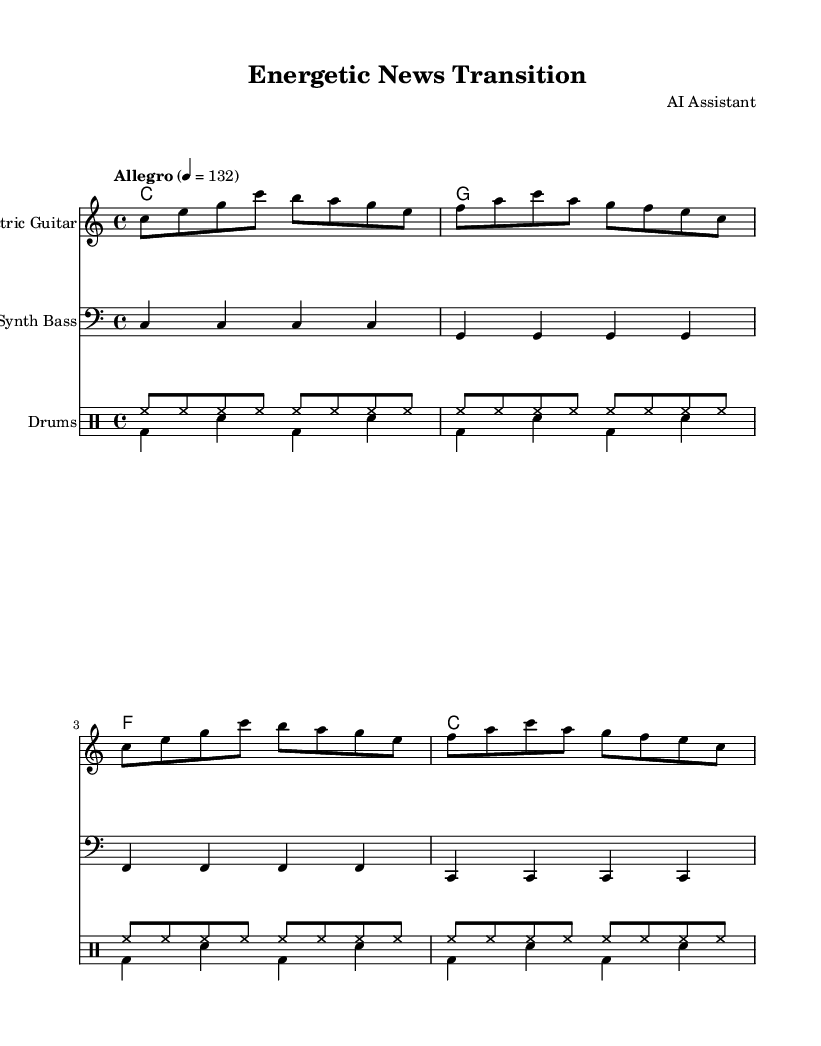What is the key signature of this music? The key signature is indicated at the beginning of the staff, showing no sharps or flats. This corresponds to the key of C major.
Answer: C major What is the time signature of this piece? The time signature is shown at the beginning of the sheet music, represented as 4/4, which means there are four beats in each measure.
Answer: 4/4 What tempo marking is indicated for this piece? The tempo marking is written above the staff, stating "Allegro" with a metronome marking of 132, indicating a fast pace.
Answer: 132 How many measures does the electric guitar part have? By counting the measures in the electric guitar staff, we note that there are eight measures in total.
Answer: 8 Which instrument is written in the bass clef? The staff labeled "Synth Bass" uses the bass clef, indicating that this part is performed by a bass instrument.
Answer: Synth Bass How many times does the hi-hat appear in the drum part? The hi-hat is indicated by the note symbol and appears consistently in every measure of the "drumsUp" section, totaling 32 hi-hat strikes across four measures.
Answer: 32 What chords are used in this piece? The chord progression shown in the chord names section is C, G, F, and C which are common chords in many pop compositions.
Answer: C, G, F, C 